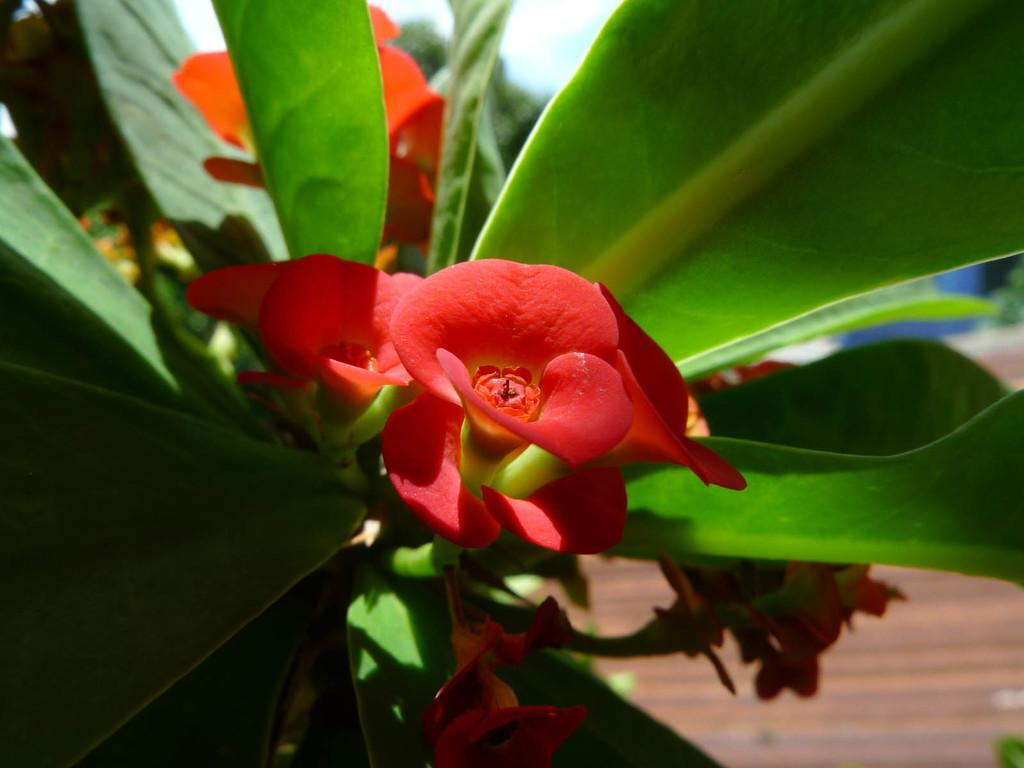What type of living organisms can be seen in the image? Plants and flowers are visible in the image. What part of the natural environment is visible in the image? The ground is visible in the image. What type of notebook is being used to write on the beds in the image? There is no notebook or beds present in the image; it features plants and flowers. How does the stretch of the flowers appear in the image? The flowers do not appear to be stretching in the image; they are stationary. 